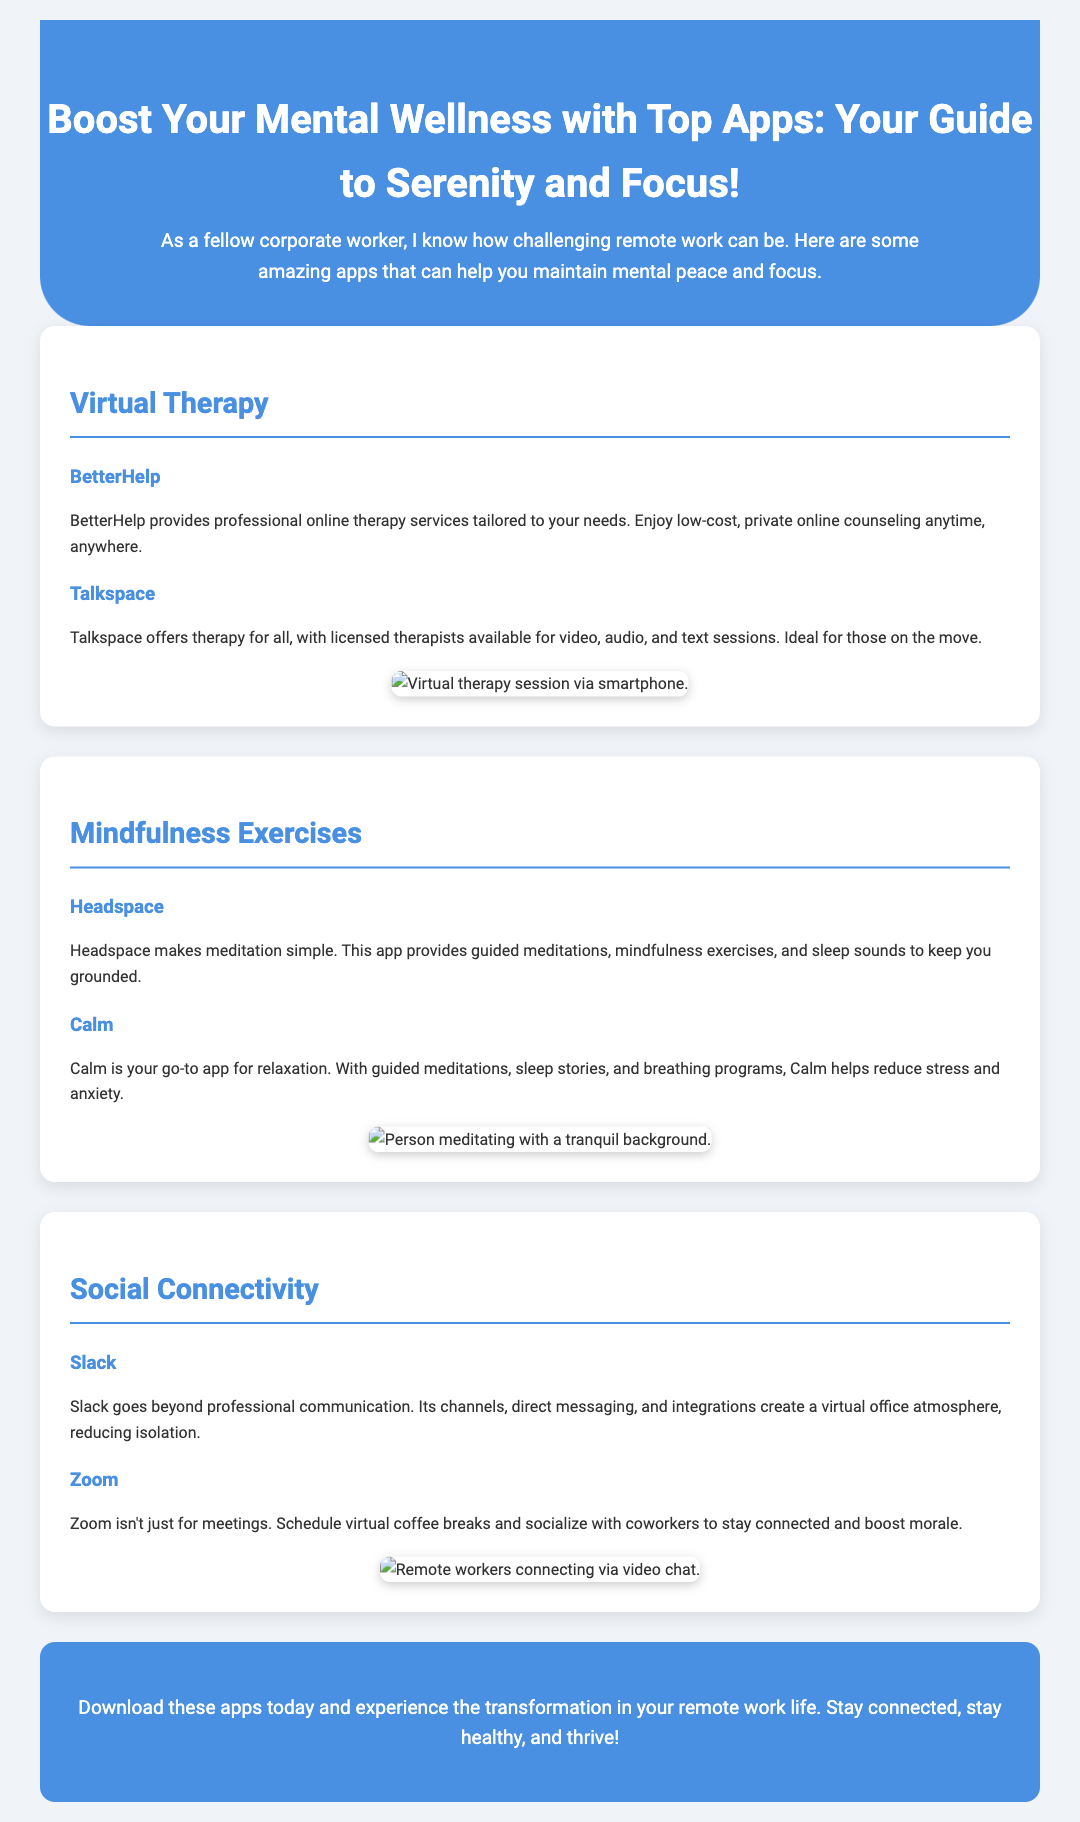What is the title of the document? The title of the document is found in the header section, which provides the main topic focused on mental wellness apps for remote workers.
Answer: Boost Your Mental Wellness with Top Apps: Your Guide to Serenity and Focus! How many virtual therapy apps are listed? The virtual therapy section includes two specific apps mentioned in the document.
Answer: 2 What app provides mindfulness exercises? The app specifically mentioned for mindfulness exercises is highlighted in the document section about mindfulness.
Answer: Headspace What color is the header background? The background color of the header can be determined by examining the style specified in the header section of the document.
Answer: #4a90e2 Which app focuses on social connectivity? The app focusing on social connectivity is mentioned in the corresponding section that describes apps which create communication among remote workers.
Answer: Slack What type of app is Calm? Calm is identified as an app that focuses on meditation and relaxation within the mindfulness exercise section.
Answer: Relaxation How does Zoom help remote workers? The document describes Zoom's function in the context of social interaction rather than just for meetings, showing its role in connecting remote teams.
Answer: Schedule virtual coffee breaks What is the call-to-action in the document? The call-to-action is a specific suggestion presented at the end of the document to encourage engaging with the apps mentioned throughout the advertisement.
Answer: Download these apps today! 